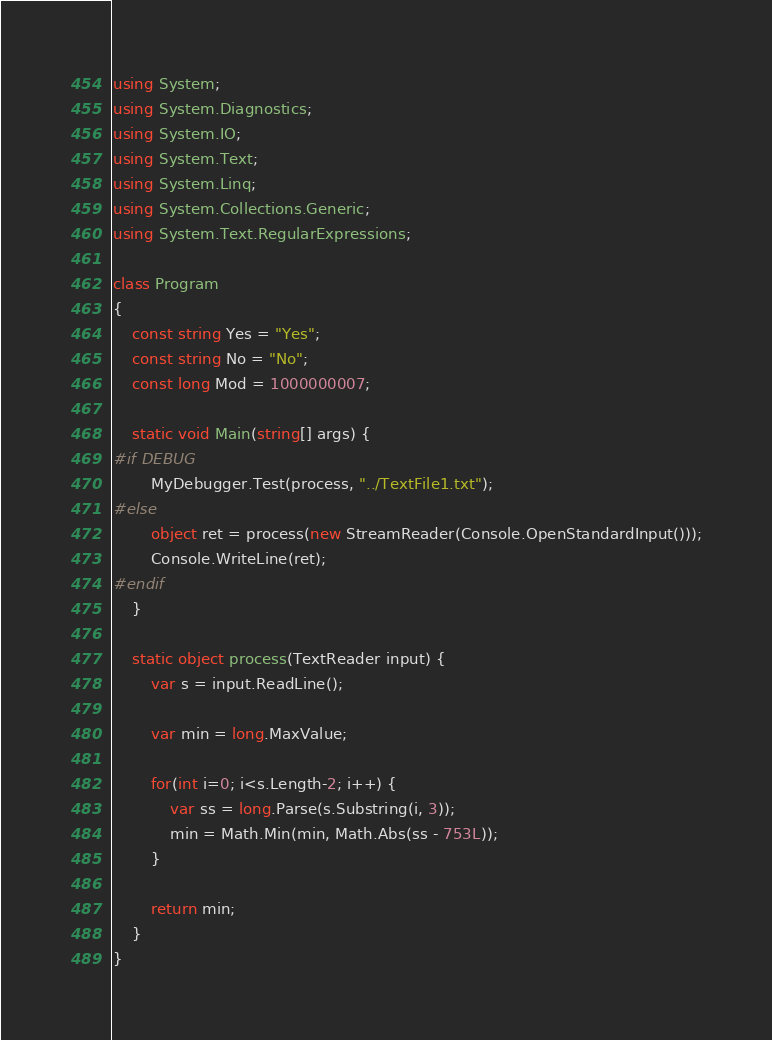Convert code to text. <code><loc_0><loc_0><loc_500><loc_500><_C#_>using System;
using System.Diagnostics;
using System.IO;
using System.Text;
using System.Linq;
using System.Collections.Generic;
using System.Text.RegularExpressions;

class Program
{
    const string Yes = "Yes";
    const string No = "No";
    const long Mod = 1000000007;

    static void Main(string[] args) {
#if DEBUG
        MyDebugger.Test(process, "../TextFile1.txt");
#else
        object ret = process(new StreamReader(Console.OpenStandardInput()));
        Console.WriteLine(ret);
#endif
    }

    static object process(TextReader input) {
        var s = input.ReadLine();

        var min = long.MaxValue;

        for(int i=0; i<s.Length-2; i++) {
            var ss = long.Parse(s.Substring(i, 3));
            min = Math.Min(min, Math.Abs(ss - 753L));
        }

        return min;
    }
}
</code> 